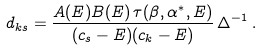<formula> <loc_0><loc_0><loc_500><loc_500>d _ { k s } = \frac { A ( E ) B ( E ) \, \tau ( \beta , \alpha ^ { * } , E ) } { ( c _ { s } - E ) ( c _ { k } - E ) } \, \Delta ^ { - 1 } \, .</formula> 